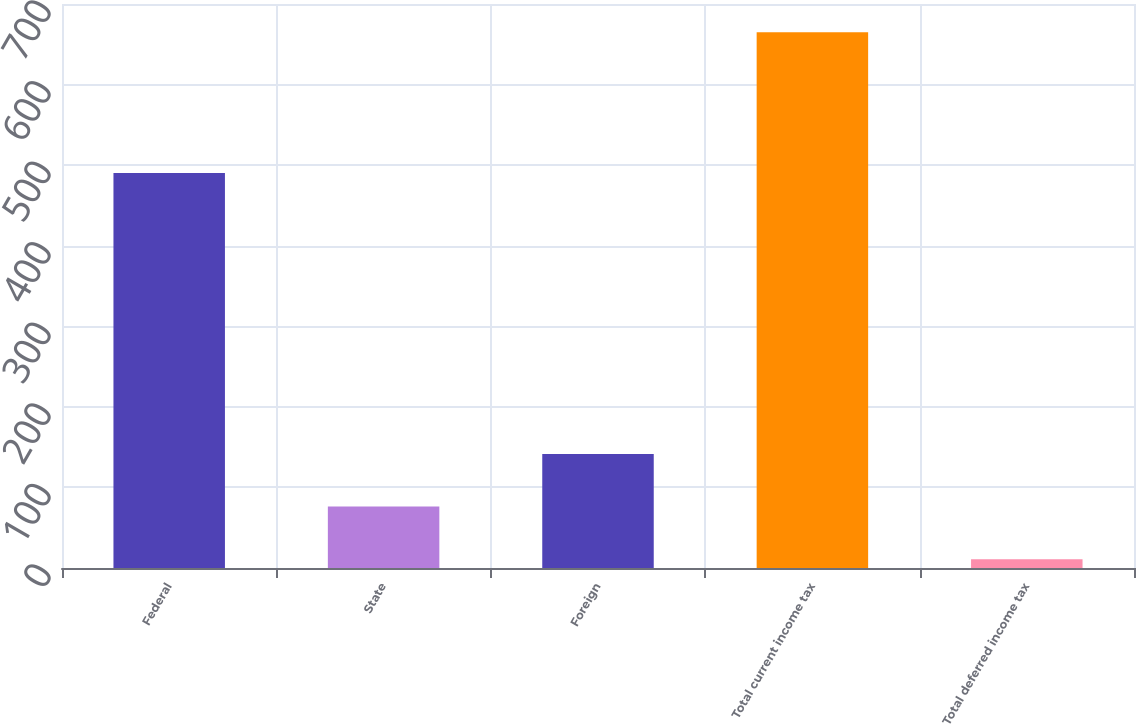Convert chart to OTSL. <chart><loc_0><loc_0><loc_500><loc_500><bar_chart><fcel>Federal<fcel>State<fcel>Foreign<fcel>Total current income tax<fcel>Total deferred income tax<nl><fcel>490.2<fcel>76.22<fcel>141.64<fcel>665<fcel>10.8<nl></chart> 